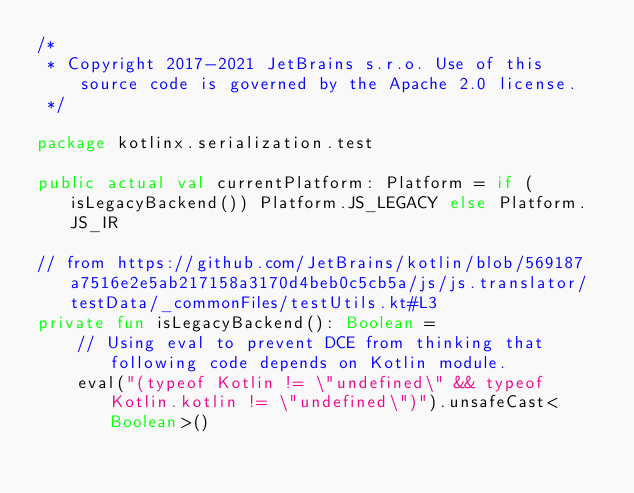Convert code to text. <code><loc_0><loc_0><loc_500><loc_500><_Kotlin_>/*
 * Copyright 2017-2021 JetBrains s.r.o. Use of this source code is governed by the Apache 2.0 license.
 */

package kotlinx.serialization.test

public actual val currentPlatform: Platform = if (isLegacyBackend()) Platform.JS_LEGACY else Platform.JS_IR

// from https://github.com/JetBrains/kotlin/blob/569187a7516e2e5ab217158a3170d4beb0c5cb5a/js/js.translator/testData/_commonFiles/testUtils.kt#L3
private fun isLegacyBackend(): Boolean =
    // Using eval to prevent DCE from thinking that following code depends on Kotlin module.
    eval("(typeof Kotlin != \"undefined\" && typeof Kotlin.kotlin != \"undefined\")").unsafeCast<Boolean>()
</code> 